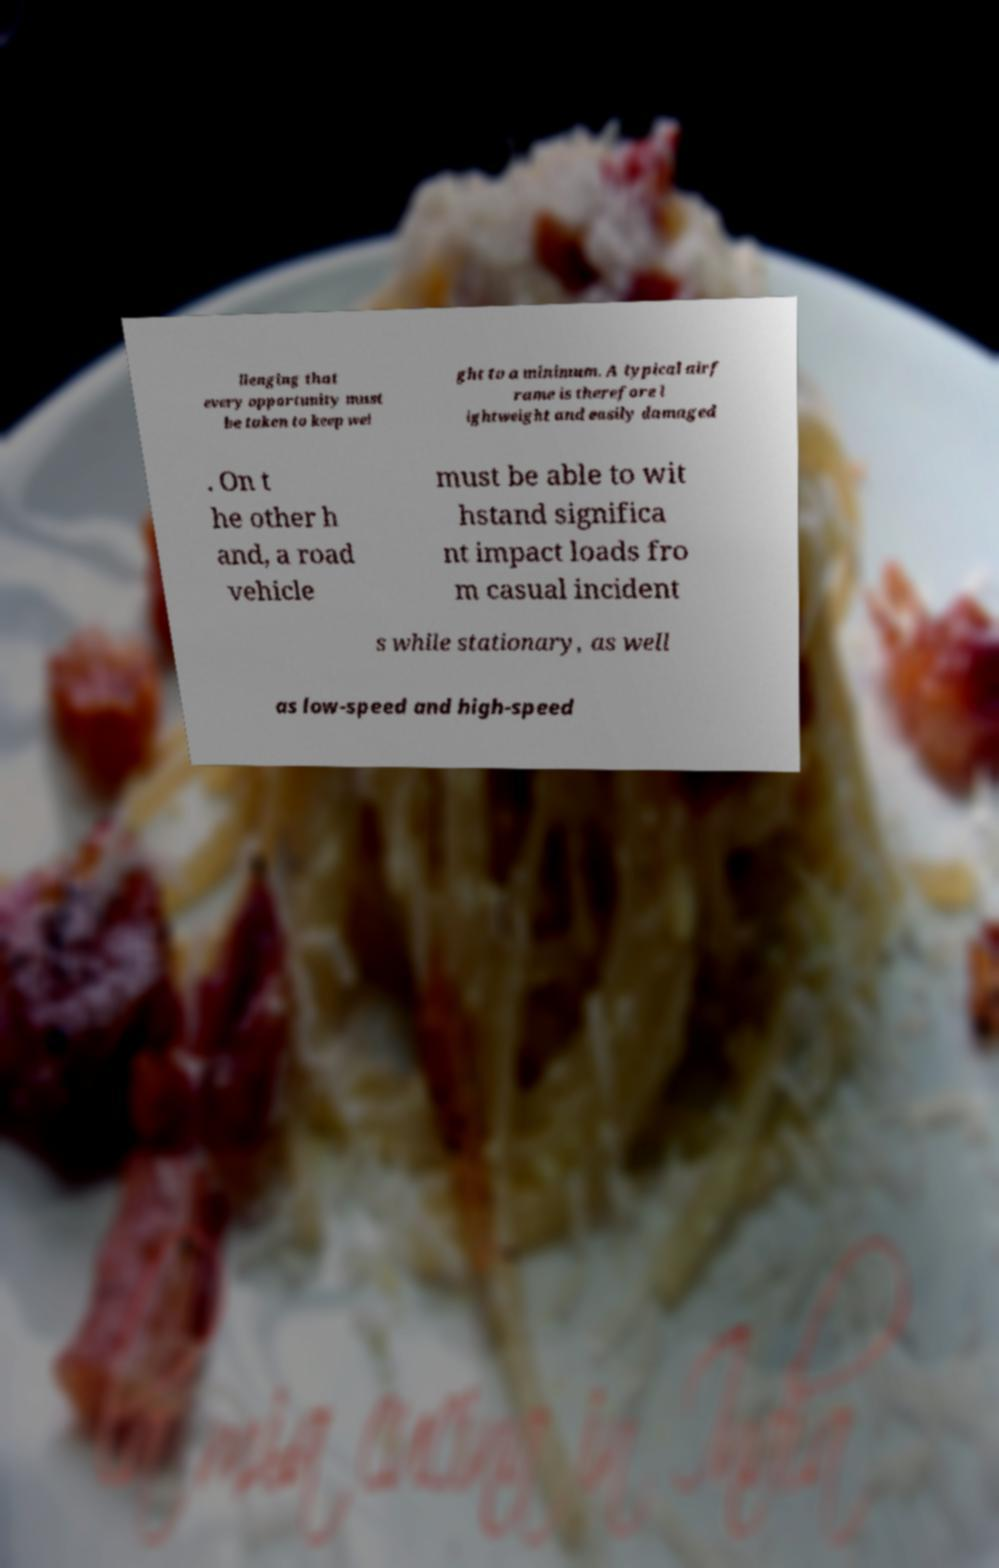I need the written content from this picture converted into text. Can you do that? llenging that every opportunity must be taken to keep wei ght to a minimum. A typical airf rame is therefore l ightweight and easily damaged . On t he other h and, a road vehicle must be able to wit hstand significa nt impact loads fro m casual incident s while stationary, as well as low-speed and high-speed 